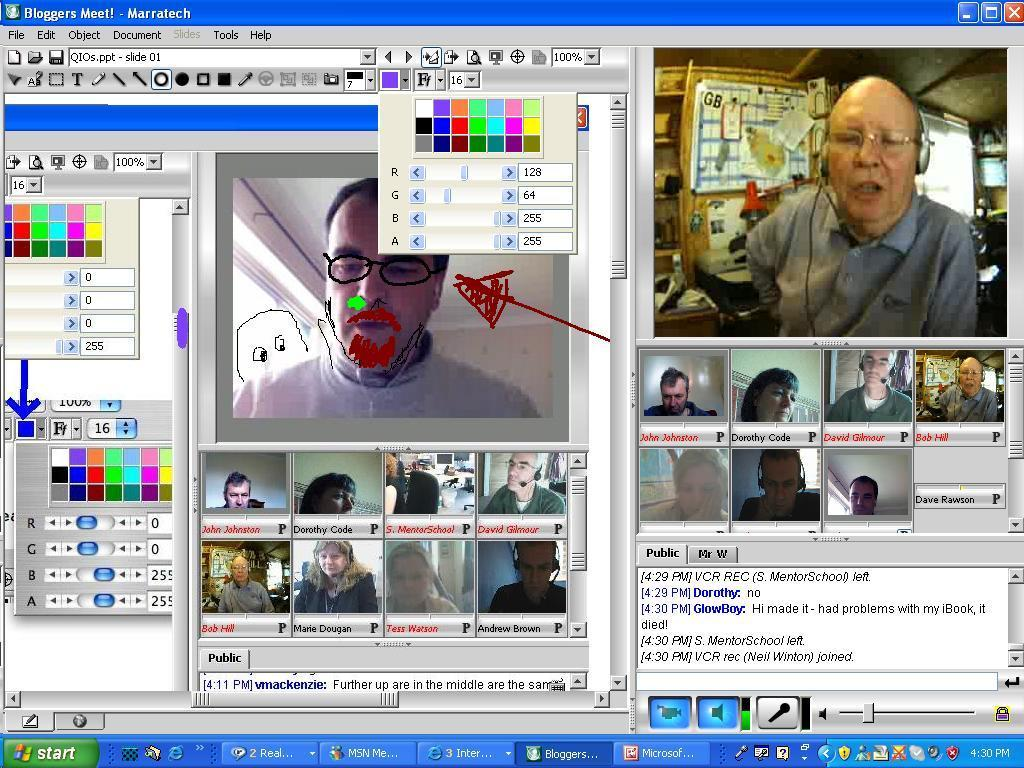What is the main subject of the image? The main subject of the image is a desktop screen of a computer. What can be seen on the computer screen? Different tabs are opened on the computer screen. How many bears are visible on the computer screen in the image? There are no bears visible on the computer screen in the image. What type of sticks can be seen being used in the image? There are no sticks present in the image, as it features a computer screen with different tabs opened. 